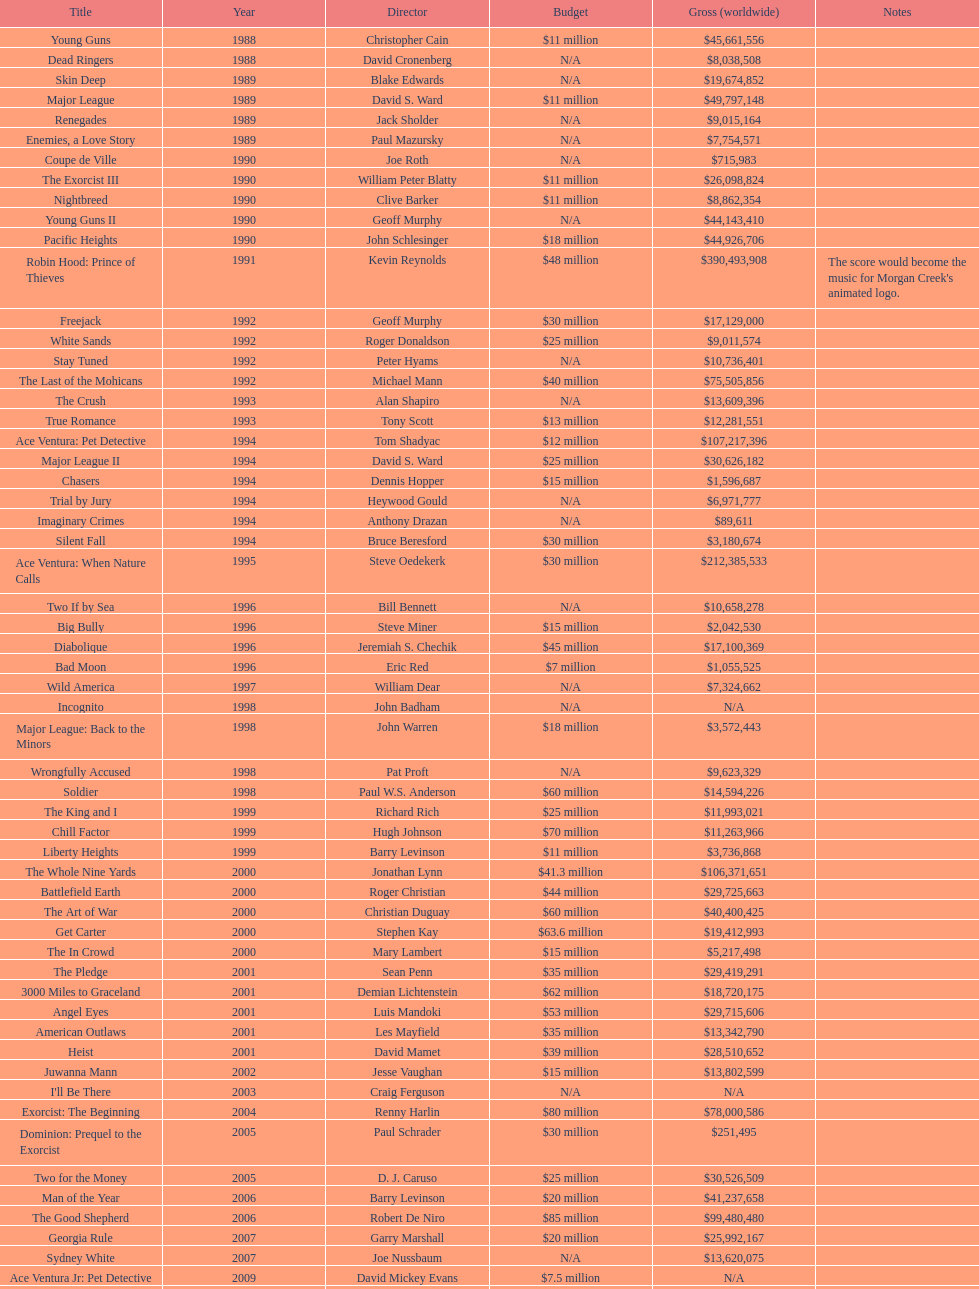What was the most recent movie morgan creek created for a budget under thirty million? Ace Ventura Jr: Pet Detective. 